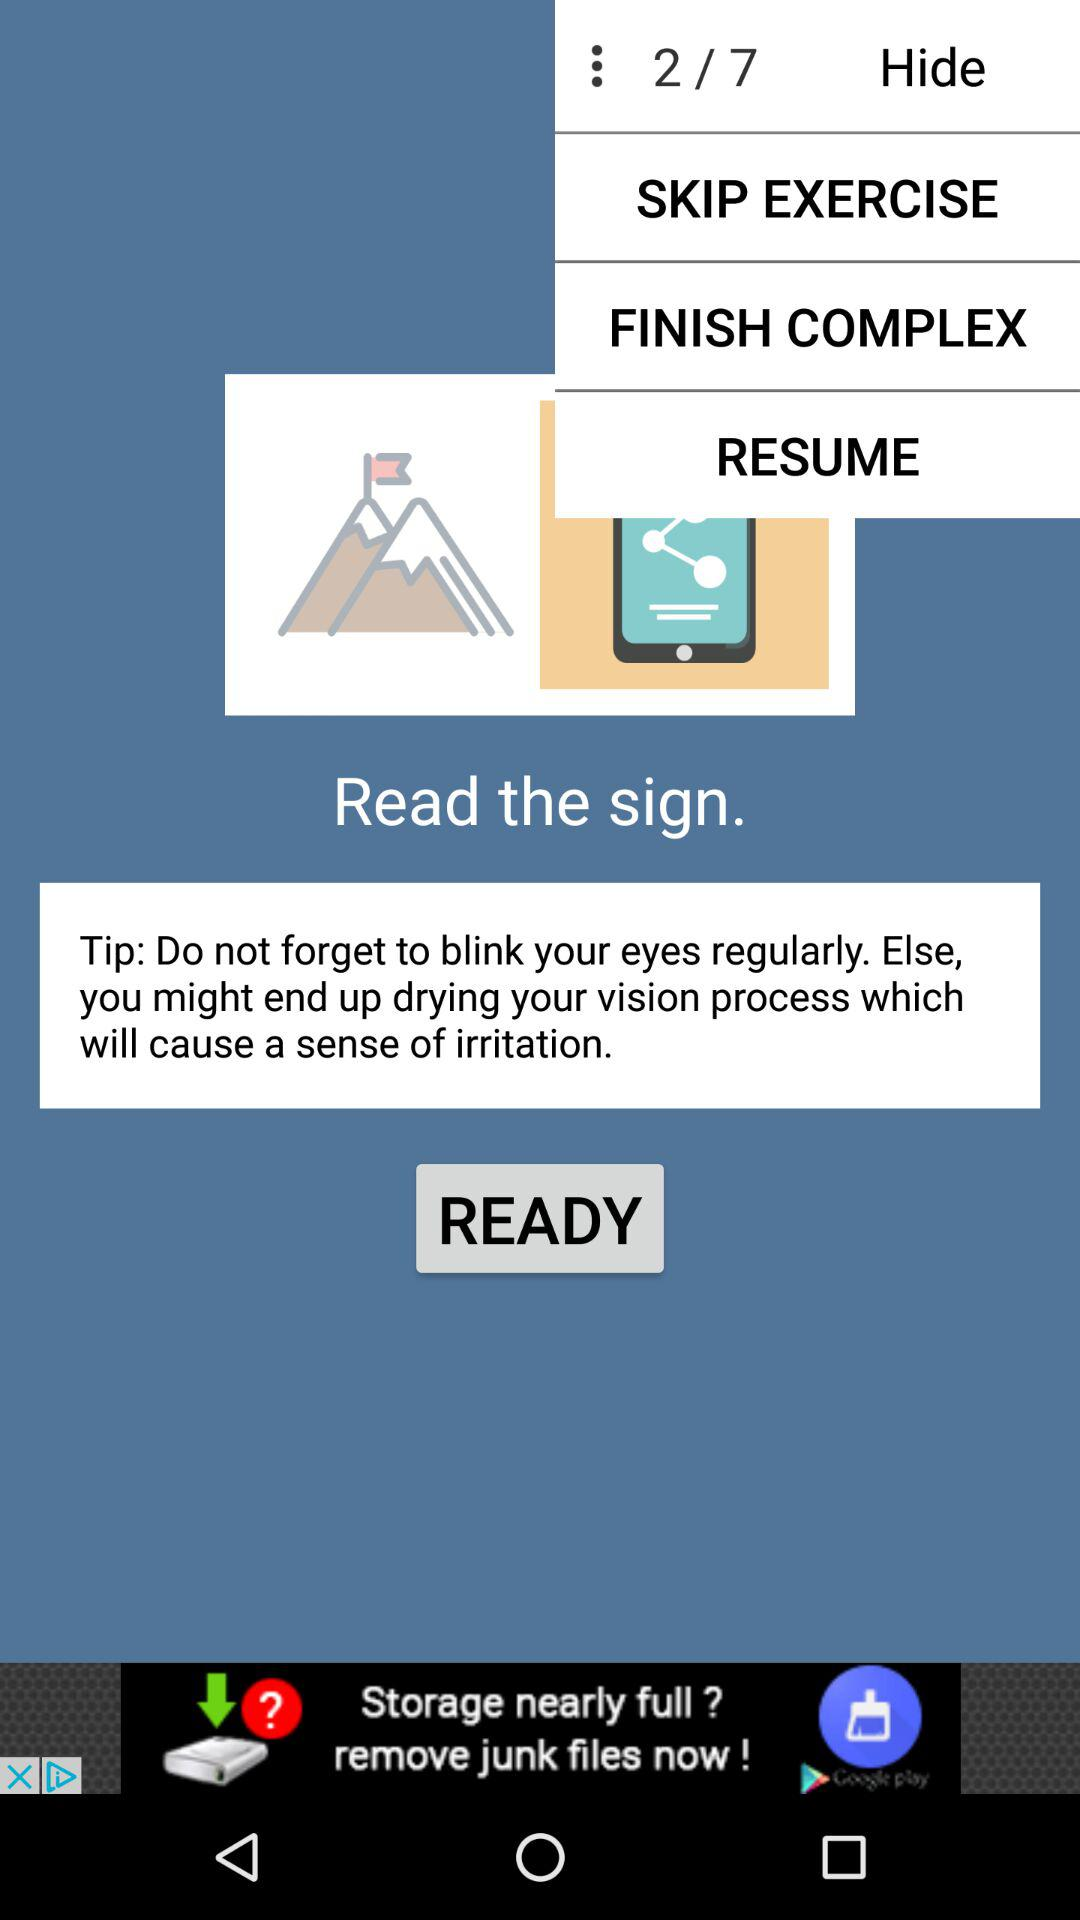How many exercises are there? There are 7 exercises. 